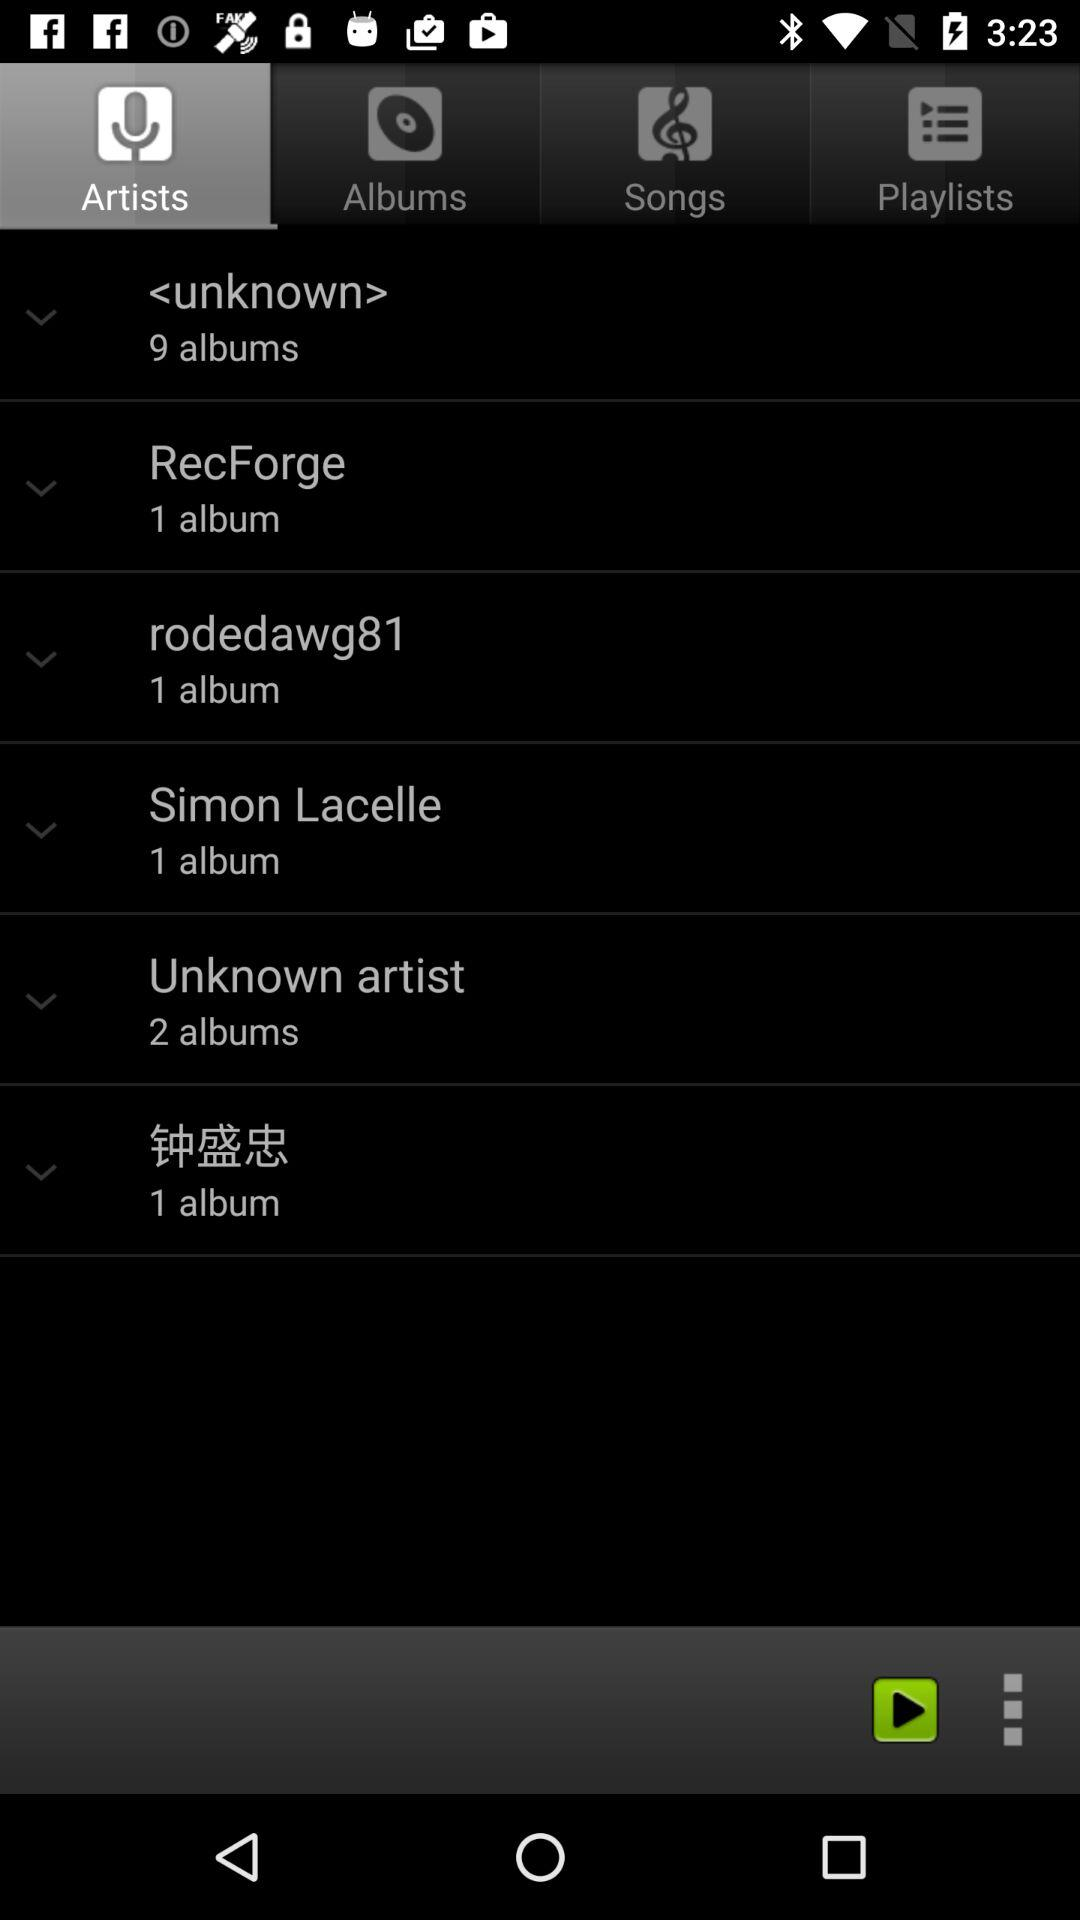How many albums are in "RecForge"? There is one album. 